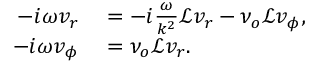Convert formula to latex. <formula><loc_0><loc_0><loc_500><loc_500>\begin{array} { r l } { - i \omega v _ { r } } & = - i \frac { \omega } { k ^ { 2 } } \mathcal { L } v _ { r } - \nu _ { o } \mathcal { L } v _ { \phi } , } \\ { - i \omega v _ { \phi } } & = \nu _ { o } \mathcal { L } v _ { r } . } \end{array}</formula> 